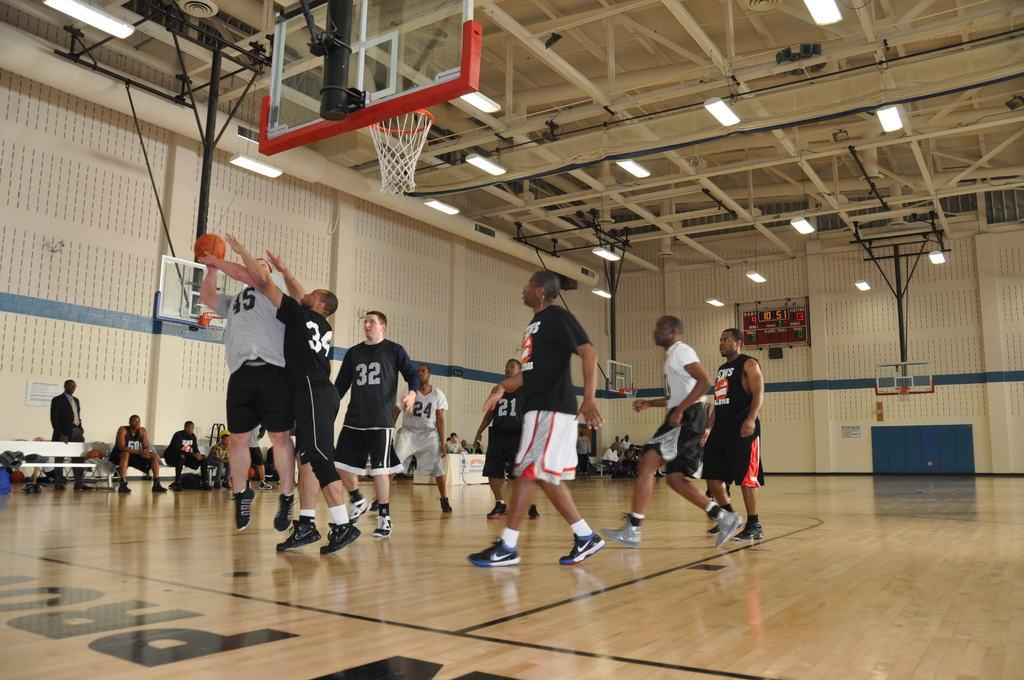How many people are in the image? There is a group of people in the image, but the exact number is not specified. What are the people doing in the image? The people are on the ground, which suggests they might be playing or sitting. What object is present in the image that is commonly used in sports? There is a ball in the image, which is often used in various sports. What structure is visible in the image that is used for playing basketball? There is a basketball hoop in the image. What type of enclosed space can be seen in the image? There are walls in the image, which suggests an enclosed space. What type of illumination is present in the image? There are lights in the image, which provide illumination. What type of structural element can be seen in the image? There are rods in the image, which are often used as support or reinforcement. What type of machine is used to produce the objects in the image? There is no indication in the image that any objects were produced by a machine. What type of hall is visible in the image? There is no hall visible in the image; only walls, lights, rods, and unspecified objects are present. 